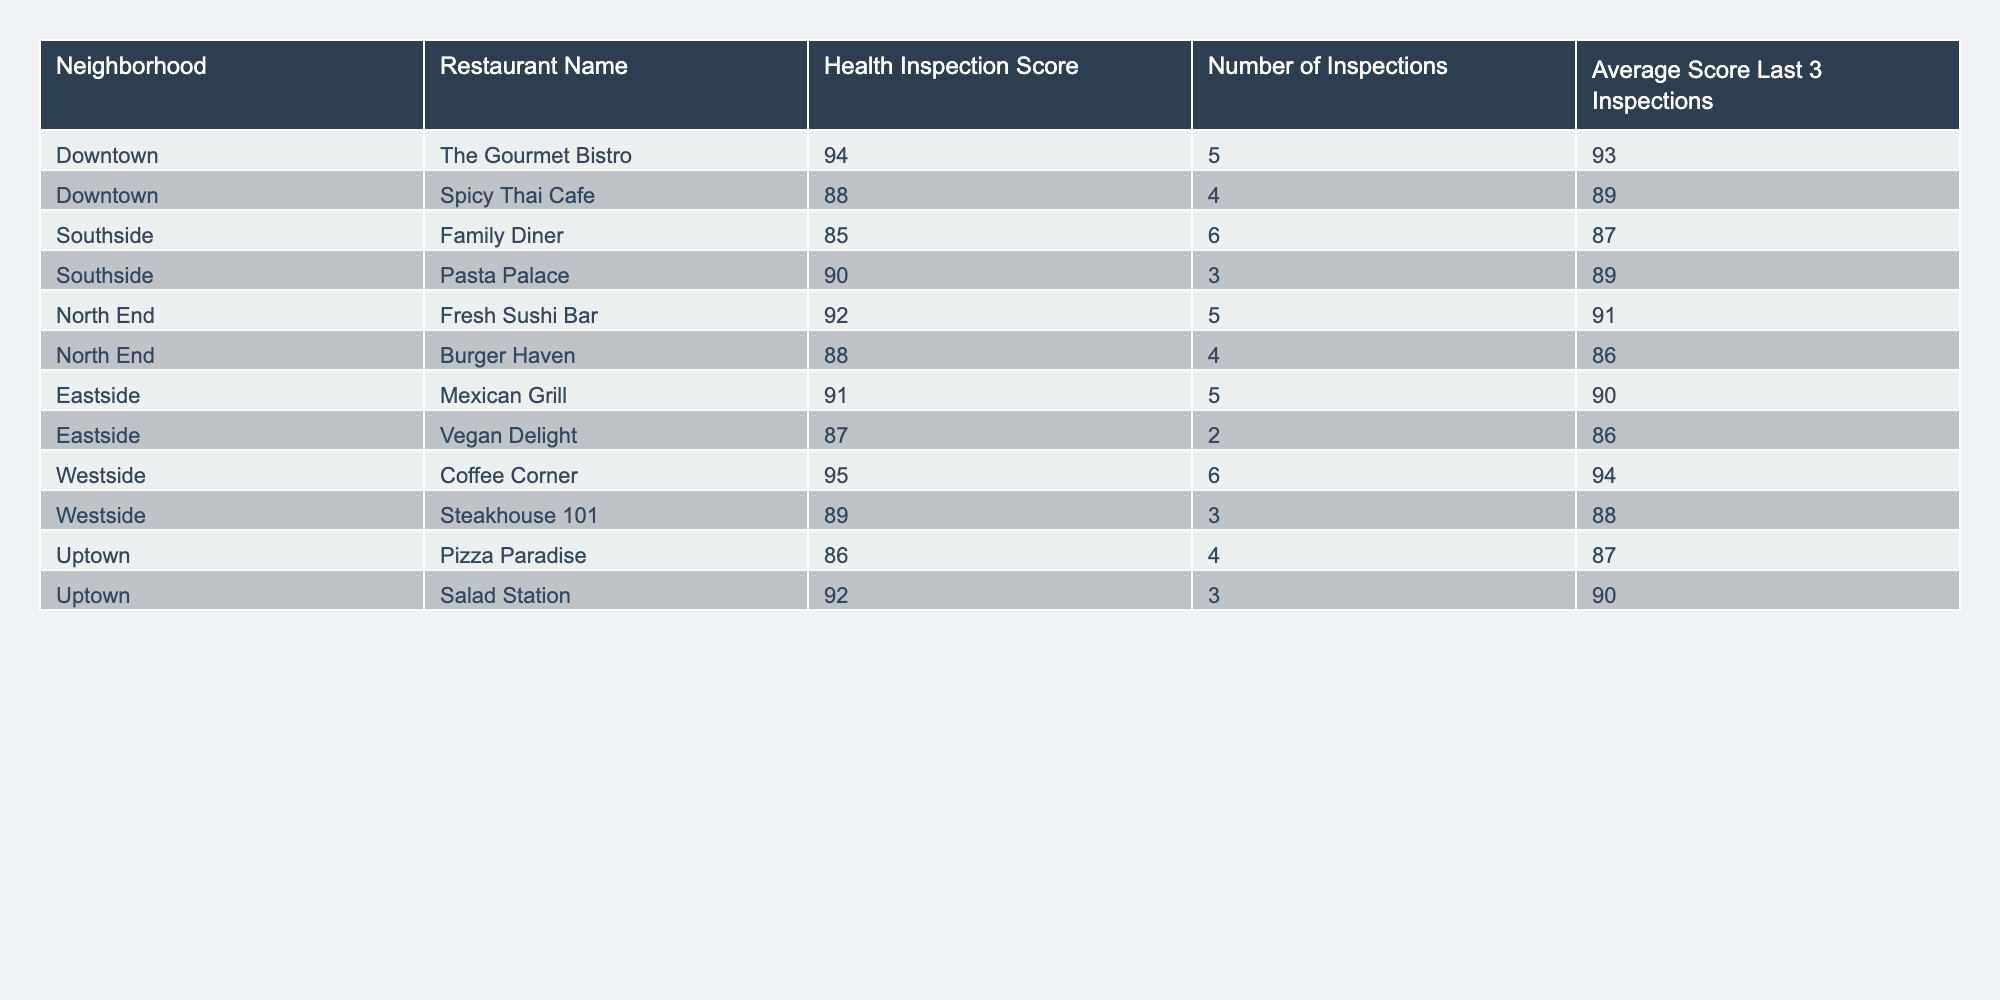what is the highest health inspection score? The highest health inspection score in the table is listed for "Coffee Corner" with a score of 95.
Answer: 95 which neighborhood has the restaurant with the lowest average score in the last 3 inspections? "Family Diner" in the "Southside" neighborhood has the lowest average score of 87 in the last 3 inspections.
Answer: Southside how many inspections did "The Gourmet Bistro" undergo? The data shows that "The Gourmet Bistro" underwent a total of 5 inspections.
Answer: 5 what is the average health inspection score of all restaurants in Uptown? To find the average score for Uptown: (86 + 92) / 2 = 89.
Answer: 89 are there any restaurants with an average score above 90 in the last 3 inspections? Yes, "The Gourmet Bistro" and "Salad Station" have an average score above 90 in the last 3 inspections.
Answer: Yes which neighborhood has the highest average health inspection score based on the last 3 inspections? The neighborhoods "North End" and "Downtown" both have average scores of 90 or higher (North End: 91, Downtown: 91).
Answer: North End, Downtown what is the total number of inspections conducted across all neighborhoods? The total number of inspections is calculated by summing all inspections: 5 + 4 + 6 + 3 + 5 + 4 + 5 + 2 + 6 + 3 + 4 + 3 = 60.
Answer: 60 which restaurant has the highest average score from the last 3 inspections and what is that score? "The Gourmet Bistro" has the highest average score of 93 from its last 3 inspections.
Answer: 93 are there more restaurants from Downtown than from Southside? There are 2 restaurants in Downtown (The Gourmet Bistro and Spicy Thai Cafe) and 2 in Southside (Family Diner and Pasta Palace), so they are equal.
Answer: No what is the average health inspection score of restaurants in the North End? The average score for North End restaurants is calculated as (92 + 88) / 2 = 90.
Answer: 90 